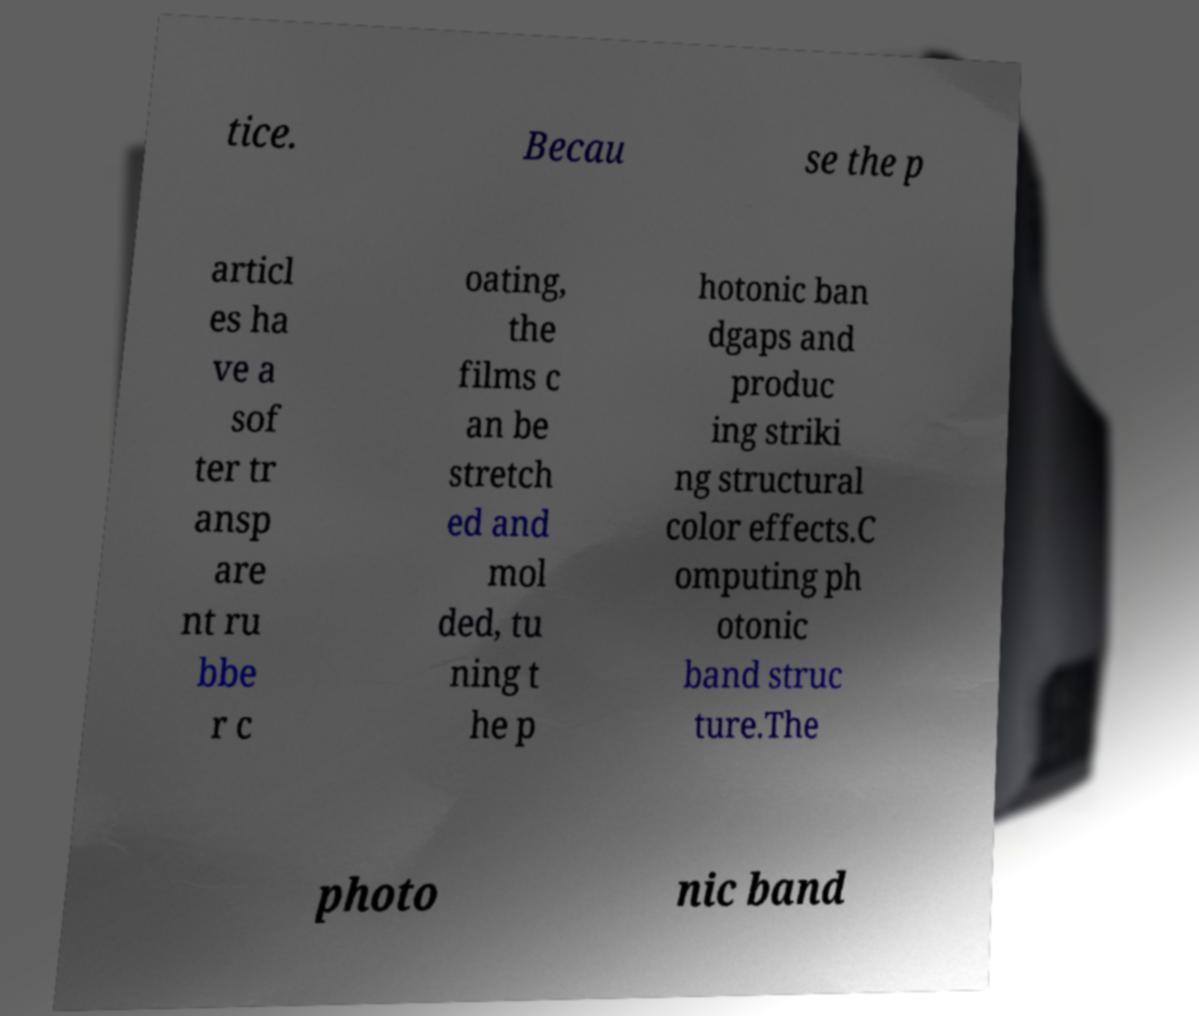Can you read and provide the text displayed in the image?This photo seems to have some interesting text. Can you extract and type it out for me? tice. Becau se the p articl es ha ve a sof ter tr ansp are nt ru bbe r c oating, the films c an be stretch ed and mol ded, tu ning t he p hotonic ban dgaps and produc ing striki ng structural color effects.C omputing ph otonic band struc ture.The photo nic band 